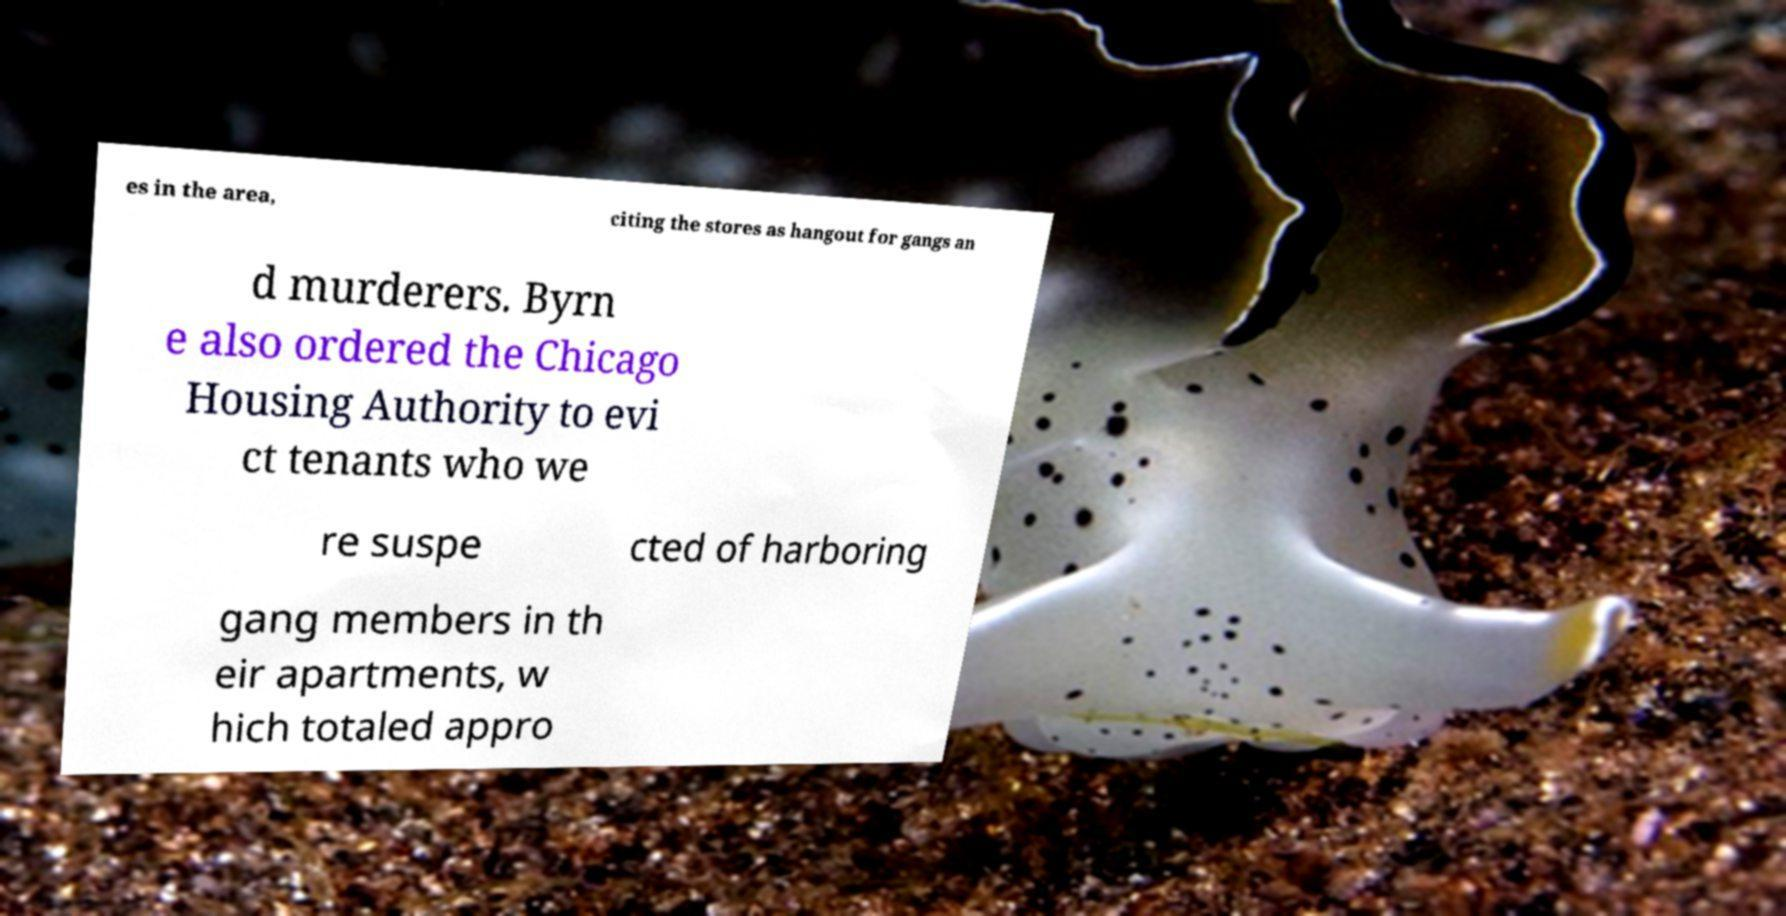Could you assist in decoding the text presented in this image and type it out clearly? es in the area, citing the stores as hangout for gangs an d murderers. Byrn e also ordered the Chicago Housing Authority to evi ct tenants who we re suspe cted of harboring gang members in th eir apartments, w hich totaled appro 